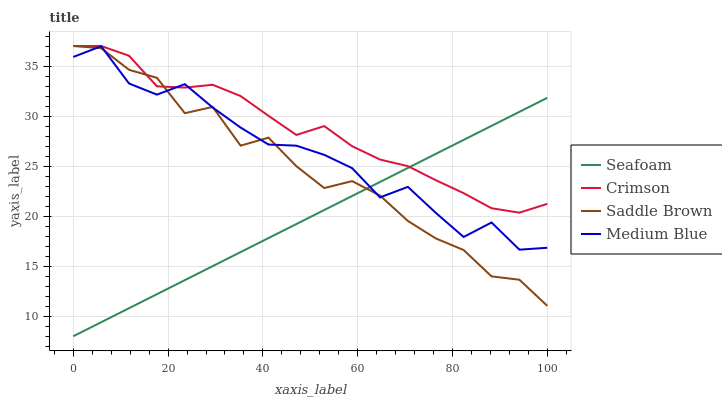Does Seafoam have the minimum area under the curve?
Answer yes or no. Yes. Does Crimson have the maximum area under the curve?
Answer yes or no. Yes. Does Medium Blue have the minimum area under the curve?
Answer yes or no. No. Does Medium Blue have the maximum area under the curve?
Answer yes or no. No. Is Seafoam the smoothest?
Answer yes or no. Yes. Is Saddle Brown the roughest?
Answer yes or no. Yes. Is Medium Blue the smoothest?
Answer yes or no. No. Is Medium Blue the roughest?
Answer yes or no. No. Does Seafoam have the lowest value?
Answer yes or no. Yes. Does Medium Blue have the lowest value?
Answer yes or no. No. Does Saddle Brown have the highest value?
Answer yes or no. Yes. Does Medium Blue have the highest value?
Answer yes or no. No. Does Saddle Brown intersect Seafoam?
Answer yes or no. Yes. Is Saddle Brown less than Seafoam?
Answer yes or no. No. Is Saddle Brown greater than Seafoam?
Answer yes or no. No. 